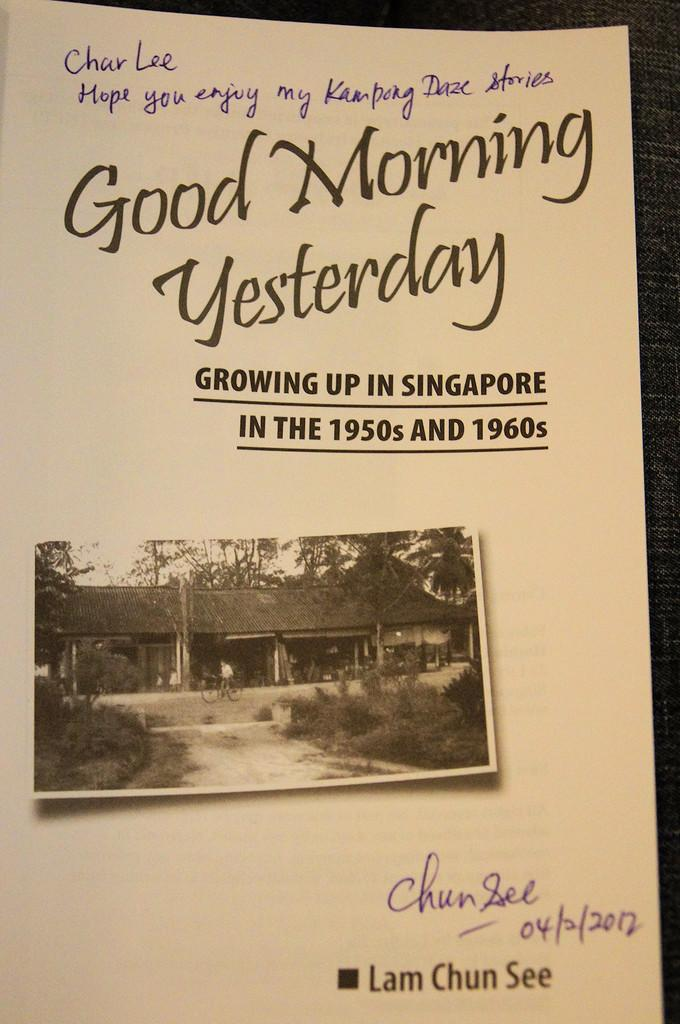<image>
Summarize the visual content of the image. A book is open to the title page that says Good Morning Yesterday and has hand written notes. 